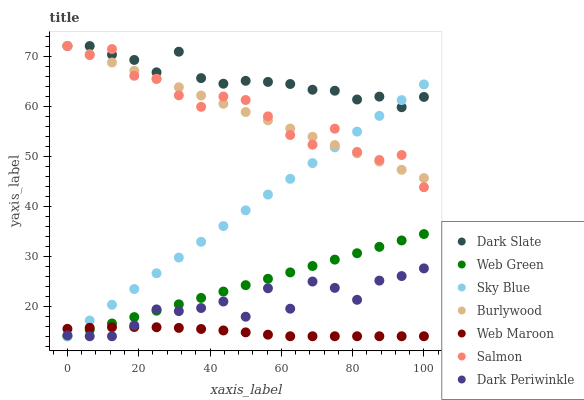Does Web Maroon have the minimum area under the curve?
Answer yes or no. Yes. Does Dark Slate have the maximum area under the curve?
Answer yes or no. Yes. Does Salmon have the minimum area under the curve?
Answer yes or no. No. Does Salmon have the maximum area under the curve?
Answer yes or no. No. Is Web Green the smoothest?
Answer yes or no. Yes. Is Dark Periwinkle the roughest?
Answer yes or no. Yes. Is Web Maroon the smoothest?
Answer yes or no. No. Is Web Maroon the roughest?
Answer yes or no. No. Does Web Maroon have the lowest value?
Answer yes or no. Yes. Does Salmon have the lowest value?
Answer yes or no. No. Does Dark Slate have the highest value?
Answer yes or no. Yes. Does Web Maroon have the highest value?
Answer yes or no. No. Is Dark Periwinkle less than Burlywood?
Answer yes or no. Yes. Is Burlywood greater than Web Maroon?
Answer yes or no. Yes. Does Dark Slate intersect Burlywood?
Answer yes or no. Yes. Is Dark Slate less than Burlywood?
Answer yes or no. No. Is Dark Slate greater than Burlywood?
Answer yes or no. No. Does Dark Periwinkle intersect Burlywood?
Answer yes or no. No. 